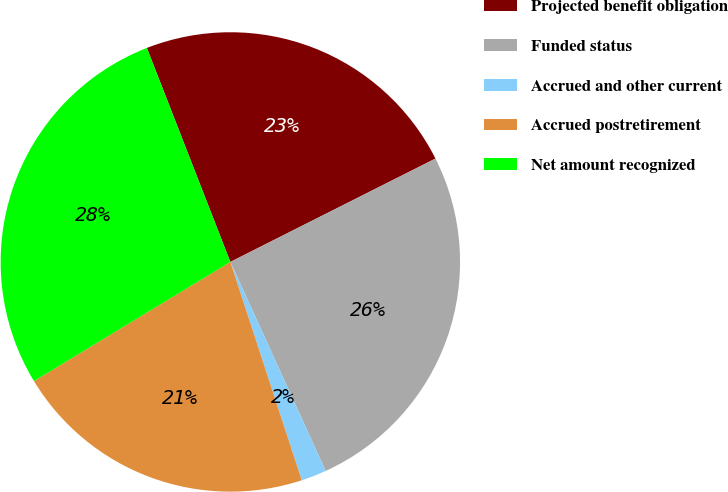<chart> <loc_0><loc_0><loc_500><loc_500><pie_chart><fcel>Projected benefit obligation<fcel>Funded status<fcel>Accrued and other current<fcel>Accrued postretirement<fcel>Net amount recognized<nl><fcel>23.49%<fcel>25.62%<fcel>1.78%<fcel>21.35%<fcel>27.76%<nl></chart> 